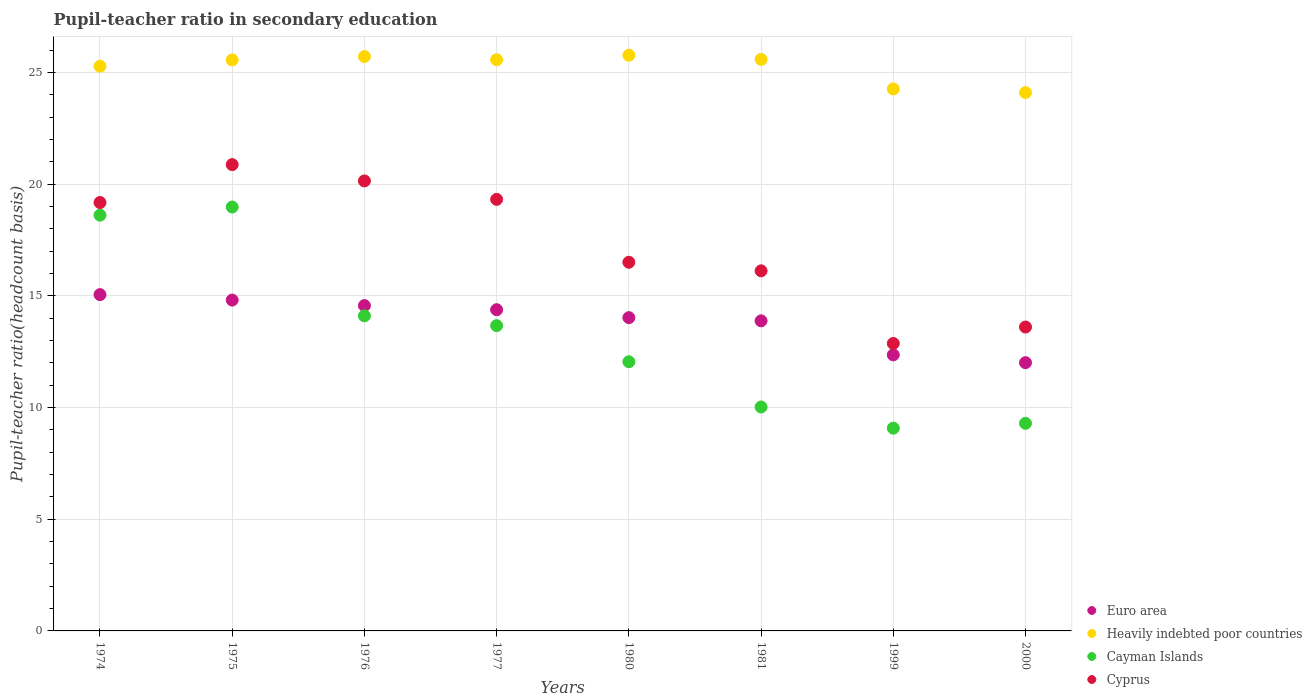Is the number of dotlines equal to the number of legend labels?
Keep it short and to the point. Yes. What is the pupil-teacher ratio in secondary education in Cayman Islands in 2000?
Your answer should be very brief. 9.29. Across all years, what is the maximum pupil-teacher ratio in secondary education in Cayman Islands?
Provide a short and direct response. 18.98. Across all years, what is the minimum pupil-teacher ratio in secondary education in Heavily indebted poor countries?
Keep it short and to the point. 24.1. What is the total pupil-teacher ratio in secondary education in Cayman Islands in the graph?
Make the answer very short. 105.8. What is the difference between the pupil-teacher ratio in secondary education in Heavily indebted poor countries in 1980 and that in 1981?
Keep it short and to the point. 0.19. What is the difference between the pupil-teacher ratio in secondary education in Cyprus in 2000 and the pupil-teacher ratio in secondary education in Heavily indebted poor countries in 1974?
Offer a very short reply. -11.67. What is the average pupil-teacher ratio in secondary education in Euro area per year?
Offer a terse response. 13.88. In the year 1981, what is the difference between the pupil-teacher ratio in secondary education in Heavily indebted poor countries and pupil-teacher ratio in secondary education in Euro area?
Give a very brief answer. 11.7. In how many years, is the pupil-teacher ratio in secondary education in Cayman Islands greater than 22?
Provide a short and direct response. 0. What is the ratio of the pupil-teacher ratio in secondary education in Euro area in 1976 to that in 1977?
Your answer should be very brief. 1.01. Is the difference between the pupil-teacher ratio in secondary education in Heavily indebted poor countries in 1976 and 2000 greater than the difference between the pupil-teacher ratio in secondary education in Euro area in 1976 and 2000?
Ensure brevity in your answer.  No. What is the difference between the highest and the second highest pupil-teacher ratio in secondary education in Cayman Islands?
Your answer should be compact. 0.36. What is the difference between the highest and the lowest pupil-teacher ratio in secondary education in Euro area?
Provide a short and direct response. 3.05. In how many years, is the pupil-teacher ratio in secondary education in Cayman Islands greater than the average pupil-teacher ratio in secondary education in Cayman Islands taken over all years?
Make the answer very short. 4. Is the sum of the pupil-teacher ratio in secondary education in Cyprus in 1977 and 1981 greater than the maximum pupil-teacher ratio in secondary education in Euro area across all years?
Offer a very short reply. Yes. Is it the case that in every year, the sum of the pupil-teacher ratio in secondary education in Heavily indebted poor countries and pupil-teacher ratio in secondary education in Cayman Islands  is greater than the sum of pupil-teacher ratio in secondary education in Cyprus and pupil-teacher ratio in secondary education in Euro area?
Give a very brief answer. Yes. Is the pupil-teacher ratio in secondary education in Cayman Islands strictly less than the pupil-teacher ratio in secondary education in Heavily indebted poor countries over the years?
Ensure brevity in your answer.  Yes. How many years are there in the graph?
Provide a short and direct response. 8. Does the graph contain any zero values?
Offer a terse response. No. How are the legend labels stacked?
Offer a terse response. Vertical. What is the title of the graph?
Ensure brevity in your answer.  Pupil-teacher ratio in secondary education. Does "Chad" appear as one of the legend labels in the graph?
Provide a succinct answer. No. What is the label or title of the Y-axis?
Offer a very short reply. Pupil-teacher ratio(headcount basis). What is the Pupil-teacher ratio(headcount basis) of Euro area in 1974?
Keep it short and to the point. 15.05. What is the Pupil-teacher ratio(headcount basis) in Heavily indebted poor countries in 1974?
Your answer should be very brief. 25.28. What is the Pupil-teacher ratio(headcount basis) of Cayman Islands in 1974?
Provide a short and direct response. 18.61. What is the Pupil-teacher ratio(headcount basis) in Cyprus in 1974?
Ensure brevity in your answer.  19.18. What is the Pupil-teacher ratio(headcount basis) in Euro area in 1975?
Make the answer very short. 14.81. What is the Pupil-teacher ratio(headcount basis) of Heavily indebted poor countries in 1975?
Ensure brevity in your answer.  25.56. What is the Pupil-teacher ratio(headcount basis) of Cayman Islands in 1975?
Your answer should be very brief. 18.98. What is the Pupil-teacher ratio(headcount basis) of Cyprus in 1975?
Provide a short and direct response. 20.87. What is the Pupil-teacher ratio(headcount basis) in Euro area in 1976?
Your response must be concise. 14.56. What is the Pupil-teacher ratio(headcount basis) of Heavily indebted poor countries in 1976?
Ensure brevity in your answer.  25.71. What is the Pupil-teacher ratio(headcount basis) in Cayman Islands in 1976?
Your answer should be compact. 14.1. What is the Pupil-teacher ratio(headcount basis) in Cyprus in 1976?
Your response must be concise. 20.14. What is the Pupil-teacher ratio(headcount basis) of Euro area in 1977?
Keep it short and to the point. 14.38. What is the Pupil-teacher ratio(headcount basis) of Heavily indebted poor countries in 1977?
Offer a very short reply. 25.57. What is the Pupil-teacher ratio(headcount basis) of Cayman Islands in 1977?
Keep it short and to the point. 13.67. What is the Pupil-teacher ratio(headcount basis) of Cyprus in 1977?
Your answer should be very brief. 19.32. What is the Pupil-teacher ratio(headcount basis) in Euro area in 1980?
Keep it short and to the point. 14.02. What is the Pupil-teacher ratio(headcount basis) in Heavily indebted poor countries in 1980?
Ensure brevity in your answer.  25.77. What is the Pupil-teacher ratio(headcount basis) in Cayman Islands in 1980?
Provide a short and direct response. 12.05. What is the Pupil-teacher ratio(headcount basis) of Cyprus in 1980?
Keep it short and to the point. 16.5. What is the Pupil-teacher ratio(headcount basis) in Euro area in 1981?
Offer a terse response. 13.88. What is the Pupil-teacher ratio(headcount basis) in Heavily indebted poor countries in 1981?
Ensure brevity in your answer.  25.58. What is the Pupil-teacher ratio(headcount basis) in Cayman Islands in 1981?
Offer a very short reply. 10.02. What is the Pupil-teacher ratio(headcount basis) in Cyprus in 1981?
Offer a terse response. 16.12. What is the Pupil-teacher ratio(headcount basis) of Euro area in 1999?
Your response must be concise. 12.36. What is the Pupil-teacher ratio(headcount basis) of Heavily indebted poor countries in 1999?
Offer a terse response. 24.26. What is the Pupil-teacher ratio(headcount basis) of Cayman Islands in 1999?
Your answer should be very brief. 9.08. What is the Pupil-teacher ratio(headcount basis) in Cyprus in 1999?
Give a very brief answer. 12.87. What is the Pupil-teacher ratio(headcount basis) in Euro area in 2000?
Provide a succinct answer. 12.01. What is the Pupil-teacher ratio(headcount basis) of Heavily indebted poor countries in 2000?
Keep it short and to the point. 24.1. What is the Pupil-teacher ratio(headcount basis) of Cayman Islands in 2000?
Provide a short and direct response. 9.29. What is the Pupil-teacher ratio(headcount basis) of Cyprus in 2000?
Ensure brevity in your answer.  13.6. Across all years, what is the maximum Pupil-teacher ratio(headcount basis) of Euro area?
Ensure brevity in your answer.  15.05. Across all years, what is the maximum Pupil-teacher ratio(headcount basis) in Heavily indebted poor countries?
Provide a short and direct response. 25.77. Across all years, what is the maximum Pupil-teacher ratio(headcount basis) of Cayman Islands?
Offer a very short reply. 18.98. Across all years, what is the maximum Pupil-teacher ratio(headcount basis) in Cyprus?
Make the answer very short. 20.87. Across all years, what is the minimum Pupil-teacher ratio(headcount basis) of Euro area?
Offer a terse response. 12.01. Across all years, what is the minimum Pupil-teacher ratio(headcount basis) of Heavily indebted poor countries?
Provide a succinct answer. 24.1. Across all years, what is the minimum Pupil-teacher ratio(headcount basis) in Cayman Islands?
Offer a terse response. 9.08. Across all years, what is the minimum Pupil-teacher ratio(headcount basis) of Cyprus?
Keep it short and to the point. 12.87. What is the total Pupil-teacher ratio(headcount basis) in Euro area in the graph?
Ensure brevity in your answer.  111.08. What is the total Pupil-teacher ratio(headcount basis) in Heavily indebted poor countries in the graph?
Offer a very short reply. 201.83. What is the total Pupil-teacher ratio(headcount basis) in Cayman Islands in the graph?
Provide a succinct answer. 105.8. What is the total Pupil-teacher ratio(headcount basis) in Cyprus in the graph?
Make the answer very short. 138.6. What is the difference between the Pupil-teacher ratio(headcount basis) in Euro area in 1974 and that in 1975?
Keep it short and to the point. 0.24. What is the difference between the Pupil-teacher ratio(headcount basis) in Heavily indebted poor countries in 1974 and that in 1975?
Your answer should be compact. -0.28. What is the difference between the Pupil-teacher ratio(headcount basis) in Cayman Islands in 1974 and that in 1975?
Provide a short and direct response. -0.36. What is the difference between the Pupil-teacher ratio(headcount basis) in Cyprus in 1974 and that in 1975?
Offer a terse response. -1.7. What is the difference between the Pupil-teacher ratio(headcount basis) of Euro area in 1974 and that in 1976?
Your answer should be very brief. 0.49. What is the difference between the Pupil-teacher ratio(headcount basis) in Heavily indebted poor countries in 1974 and that in 1976?
Offer a terse response. -0.43. What is the difference between the Pupil-teacher ratio(headcount basis) of Cayman Islands in 1974 and that in 1976?
Give a very brief answer. 4.51. What is the difference between the Pupil-teacher ratio(headcount basis) in Cyprus in 1974 and that in 1976?
Provide a short and direct response. -0.97. What is the difference between the Pupil-teacher ratio(headcount basis) of Euro area in 1974 and that in 1977?
Make the answer very short. 0.68. What is the difference between the Pupil-teacher ratio(headcount basis) in Heavily indebted poor countries in 1974 and that in 1977?
Your answer should be compact. -0.29. What is the difference between the Pupil-teacher ratio(headcount basis) of Cayman Islands in 1974 and that in 1977?
Offer a terse response. 4.94. What is the difference between the Pupil-teacher ratio(headcount basis) of Cyprus in 1974 and that in 1977?
Your answer should be compact. -0.14. What is the difference between the Pupil-teacher ratio(headcount basis) of Euro area in 1974 and that in 1980?
Your response must be concise. 1.03. What is the difference between the Pupil-teacher ratio(headcount basis) in Heavily indebted poor countries in 1974 and that in 1980?
Offer a very short reply. -0.49. What is the difference between the Pupil-teacher ratio(headcount basis) in Cayman Islands in 1974 and that in 1980?
Provide a short and direct response. 6.56. What is the difference between the Pupil-teacher ratio(headcount basis) of Cyprus in 1974 and that in 1980?
Keep it short and to the point. 2.67. What is the difference between the Pupil-teacher ratio(headcount basis) in Euro area in 1974 and that in 1981?
Provide a succinct answer. 1.17. What is the difference between the Pupil-teacher ratio(headcount basis) in Heavily indebted poor countries in 1974 and that in 1981?
Make the answer very short. -0.31. What is the difference between the Pupil-teacher ratio(headcount basis) of Cayman Islands in 1974 and that in 1981?
Provide a succinct answer. 8.59. What is the difference between the Pupil-teacher ratio(headcount basis) in Cyprus in 1974 and that in 1981?
Provide a succinct answer. 3.06. What is the difference between the Pupil-teacher ratio(headcount basis) in Euro area in 1974 and that in 1999?
Give a very brief answer. 2.7. What is the difference between the Pupil-teacher ratio(headcount basis) in Heavily indebted poor countries in 1974 and that in 1999?
Keep it short and to the point. 1.02. What is the difference between the Pupil-teacher ratio(headcount basis) of Cayman Islands in 1974 and that in 1999?
Your response must be concise. 9.54. What is the difference between the Pupil-teacher ratio(headcount basis) of Cyprus in 1974 and that in 1999?
Offer a very short reply. 6.31. What is the difference between the Pupil-teacher ratio(headcount basis) of Euro area in 1974 and that in 2000?
Provide a succinct answer. 3.05. What is the difference between the Pupil-teacher ratio(headcount basis) of Heavily indebted poor countries in 1974 and that in 2000?
Your response must be concise. 1.18. What is the difference between the Pupil-teacher ratio(headcount basis) of Cayman Islands in 1974 and that in 2000?
Offer a terse response. 9.32. What is the difference between the Pupil-teacher ratio(headcount basis) in Cyprus in 1974 and that in 2000?
Provide a short and direct response. 5.57. What is the difference between the Pupil-teacher ratio(headcount basis) of Euro area in 1975 and that in 1976?
Give a very brief answer. 0.25. What is the difference between the Pupil-teacher ratio(headcount basis) in Heavily indebted poor countries in 1975 and that in 1976?
Provide a succinct answer. -0.15. What is the difference between the Pupil-teacher ratio(headcount basis) in Cayman Islands in 1975 and that in 1976?
Offer a terse response. 4.87. What is the difference between the Pupil-teacher ratio(headcount basis) in Cyprus in 1975 and that in 1976?
Keep it short and to the point. 0.73. What is the difference between the Pupil-teacher ratio(headcount basis) of Euro area in 1975 and that in 1977?
Provide a succinct answer. 0.43. What is the difference between the Pupil-teacher ratio(headcount basis) in Heavily indebted poor countries in 1975 and that in 1977?
Offer a very short reply. -0.01. What is the difference between the Pupil-teacher ratio(headcount basis) of Cayman Islands in 1975 and that in 1977?
Give a very brief answer. 5.31. What is the difference between the Pupil-teacher ratio(headcount basis) in Cyprus in 1975 and that in 1977?
Provide a succinct answer. 1.56. What is the difference between the Pupil-teacher ratio(headcount basis) in Euro area in 1975 and that in 1980?
Offer a very short reply. 0.79. What is the difference between the Pupil-teacher ratio(headcount basis) of Heavily indebted poor countries in 1975 and that in 1980?
Your response must be concise. -0.21. What is the difference between the Pupil-teacher ratio(headcount basis) of Cayman Islands in 1975 and that in 1980?
Keep it short and to the point. 6.93. What is the difference between the Pupil-teacher ratio(headcount basis) of Cyprus in 1975 and that in 1980?
Provide a short and direct response. 4.37. What is the difference between the Pupil-teacher ratio(headcount basis) of Euro area in 1975 and that in 1981?
Offer a terse response. 0.93. What is the difference between the Pupil-teacher ratio(headcount basis) in Heavily indebted poor countries in 1975 and that in 1981?
Keep it short and to the point. -0.02. What is the difference between the Pupil-teacher ratio(headcount basis) in Cayman Islands in 1975 and that in 1981?
Keep it short and to the point. 8.95. What is the difference between the Pupil-teacher ratio(headcount basis) in Cyprus in 1975 and that in 1981?
Offer a very short reply. 4.76. What is the difference between the Pupil-teacher ratio(headcount basis) of Euro area in 1975 and that in 1999?
Keep it short and to the point. 2.45. What is the difference between the Pupil-teacher ratio(headcount basis) of Heavily indebted poor countries in 1975 and that in 1999?
Your answer should be very brief. 1.3. What is the difference between the Pupil-teacher ratio(headcount basis) of Cayman Islands in 1975 and that in 1999?
Your response must be concise. 9.9. What is the difference between the Pupil-teacher ratio(headcount basis) of Cyprus in 1975 and that in 1999?
Your response must be concise. 8.01. What is the difference between the Pupil-teacher ratio(headcount basis) in Euro area in 1975 and that in 2000?
Ensure brevity in your answer.  2.8. What is the difference between the Pupil-teacher ratio(headcount basis) of Heavily indebted poor countries in 1975 and that in 2000?
Make the answer very short. 1.46. What is the difference between the Pupil-teacher ratio(headcount basis) of Cayman Islands in 1975 and that in 2000?
Your response must be concise. 9.68. What is the difference between the Pupil-teacher ratio(headcount basis) in Cyprus in 1975 and that in 2000?
Provide a short and direct response. 7.27. What is the difference between the Pupil-teacher ratio(headcount basis) of Euro area in 1976 and that in 1977?
Provide a succinct answer. 0.19. What is the difference between the Pupil-teacher ratio(headcount basis) in Heavily indebted poor countries in 1976 and that in 1977?
Your answer should be compact. 0.14. What is the difference between the Pupil-teacher ratio(headcount basis) in Cayman Islands in 1976 and that in 1977?
Ensure brevity in your answer.  0.44. What is the difference between the Pupil-teacher ratio(headcount basis) in Cyprus in 1976 and that in 1977?
Offer a terse response. 0.83. What is the difference between the Pupil-teacher ratio(headcount basis) in Euro area in 1976 and that in 1980?
Your answer should be compact. 0.54. What is the difference between the Pupil-teacher ratio(headcount basis) of Heavily indebted poor countries in 1976 and that in 1980?
Provide a succinct answer. -0.06. What is the difference between the Pupil-teacher ratio(headcount basis) of Cayman Islands in 1976 and that in 1980?
Provide a short and direct response. 2.05. What is the difference between the Pupil-teacher ratio(headcount basis) in Cyprus in 1976 and that in 1980?
Your answer should be very brief. 3.64. What is the difference between the Pupil-teacher ratio(headcount basis) of Euro area in 1976 and that in 1981?
Keep it short and to the point. 0.68. What is the difference between the Pupil-teacher ratio(headcount basis) of Heavily indebted poor countries in 1976 and that in 1981?
Provide a short and direct response. 0.13. What is the difference between the Pupil-teacher ratio(headcount basis) of Cayman Islands in 1976 and that in 1981?
Offer a terse response. 4.08. What is the difference between the Pupil-teacher ratio(headcount basis) of Cyprus in 1976 and that in 1981?
Provide a short and direct response. 4.03. What is the difference between the Pupil-teacher ratio(headcount basis) of Euro area in 1976 and that in 1999?
Your answer should be very brief. 2.21. What is the difference between the Pupil-teacher ratio(headcount basis) in Heavily indebted poor countries in 1976 and that in 1999?
Offer a very short reply. 1.45. What is the difference between the Pupil-teacher ratio(headcount basis) in Cayman Islands in 1976 and that in 1999?
Keep it short and to the point. 5.03. What is the difference between the Pupil-teacher ratio(headcount basis) of Cyprus in 1976 and that in 1999?
Provide a succinct answer. 7.28. What is the difference between the Pupil-teacher ratio(headcount basis) of Euro area in 1976 and that in 2000?
Your answer should be very brief. 2.56. What is the difference between the Pupil-teacher ratio(headcount basis) in Heavily indebted poor countries in 1976 and that in 2000?
Provide a short and direct response. 1.61. What is the difference between the Pupil-teacher ratio(headcount basis) of Cayman Islands in 1976 and that in 2000?
Keep it short and to the point. 4.81. What is the difference between the Pupil-teacher ratio(headcount basis) of Cyprus in 1976 and that in 2000?
Your response must be concise. 6.54. What is the difference between the Pupil-teacher ratio(headcount basis) of Euro area in 1977 and that in 1980?
Provide a succinct answer. 0.36. What is the difference between the Pupil-teacher ratio(headcount basis) in Heavily indebted poor countries in 1977 and that in 1980?
Give a very brief answer. -0.2. What is the difference between the Pupil-teacher ratio(headcount basis) in Cayman Islands in 1977 and that in 1980?
Keep it short and to the point. 1.62. What is the difference between the Pupil-teacher ratio(headcount basis) in Cyprus in 1977 and that in 1980?
Your answer should be very brief. 2.82. What is the difference between the Pupil-teacher ratio(headcount basis) of Euro area in 1977 and that in 1981?
Provide a short and direct response. 0.5. What is the difference between the Pupil-teacher ratio(headcount basis) of Heavily indebted poor countries in 1977 and that in 1981?
Provide a short and direct response. -0.02. What is the difference between the Pupil-teacher ratio(headcount basis) in Cayman Islands in 1977 and that in 1981?
Your answer should be compact. 3.64. What is the difference between the Pupil-teacher ratio(headcount basis) in Cyprus in 1977 and that in 1981?
Provide a succinct answer. 3.2. What is the difference between the Pupil-teacher ratio(headcount basis) in Euro area in 1977 and that in 1999?
Your response must be concise. 2.02. What is the difference between the Pupil-teacher ratio(headcount basis) of Heavily indebted poor countries in 1977 and that in 1999?
Provide a short and direct response. 1.31. What is the difference between the Pupil-teacher ratio(headcount basis) of Cayman Islands in 1977 and that in 1999?
Ensure brevity in your answer.  4.59. What is the difference between the Pupil-teacher ratio(headcount basis) of Cyprus in 1977 and that in 1999?
Offer a terse response. 6.45. What is the difference between the Pupil-teacher ratio(headcount basis) in Euro area in 1977 and that in 2000?
Your response must be concise. 2.37. What is the difference between the Pupil-teacher ratio(headcount basis) of Heavily indebted poor countries in 1977 and that in 2000?
Give a very brief answer. 1.47. What is the difference between the Pupil-teacher ratio(headcount basis) of Cayman Islands in 1977 and that in 2000?
Your response must be concise. 4.37. What is the difference between the Pupil-teacher ratio(headcount basis) in Cyprus in 1977 and that in 2000?
Provide a short and direct response. 5.71. What is the difference between the Pupil-teacher ratio(headcount basis) in Euro area in 1980 and that in 1981?
Offer a very short reply. 0.14. What is the difference between the Pupil-teacher ratio(headcount basis) of Heavily indebted poor countries in 1980 and that in 1981?
Provide a short and direct response. 0.19. What is the difference between the Pupil-teacher ratio(headcount basis) of Cayman Islands in 1980 and that in 1981?
Give a very brief answer. 2.03. What is the difference between the Pupil-teacher ratio(headcount basis) of Cyprus in 1980 and that in 1981?
Provide a short and direct response. 0.38. What is the difference between the Pupil-teacher ratio(headcount basis) in Euro area in 1980 and that in 1999?
Make the answer very short. 1.67. What is the difference between the Pupil-teacher ratio(headcount basis) in Heavily indebted poor countries in 1980 and that in 1999?
Keep it short and to the point. 1.51. What is the difference between the Pupil-teacher ratio(headcount basis) of Cayman Islands in 1980 and that in 1999?
Ensure brevity in your answer.  2.97. What is the difference between the Pupil-teacher ratio(headcount basis) in Cyprus in 1980 and that in 1999?
Provide a succinct answer. 3.63. What is the difference between the Pupil-teacher ratio(headcount basis) of Euro area in 1980 and that in 2000?
Offer a very short reply. 2.02. What is the difference between the Pupil-teacher ratio(headcount basis) in Heavily indebted poor countries in 1980 and that in 2000?
Give a very brief answer. 1.67. What is the difference between the Pupil-teacher ratio(headcount basis) in Cayman Islands in 1980 and that in 2000?
Offer a very short reply. 2.76. What is the difference between the Pupil-teacher ratio(headcount basis) in Cyprus in 1980 and that in 2000?
Keep it short and to the point. 2.9. What is the difference between the Pupil-teacher ratio(headcount basis) in Euro area in 1981 and that in 1999?
Offer a terse response. 1.52. What is the difference between the Pupil-teacher ratio(headcount basis) in Heavily indebted poor countries in 1981 and that in 1999?
Provide a short and direct response. 1.32. What is the difference between the Pupil-teacher ratio(headcount basis) of Cayman Islands in 1981 and that in 1999?
Keep it short and to the point. 0.95. What is the difference between the Pupil-teacher ratio(headcount basis) in Cyprus in 1981 and that in 1999?
Your answer should be very brief. 3.25. What is the difference between the Pupil-teacher ratio(headcount basis) of Euro area in 1981 and that in 2000?
Give a very brief answer. 1.87. What is the difference between the Pupil-teacher ratio(headcount basis) of Heavily indebted poor countries in 1981 and that in 2000?
Offer a very short reply. 1.49. What is the difference between the Pupil-teacher ratio(headcount basis) in Cayman Islands in 1981 and that in 2000?
Provide a short and direct response. 0.73. What is the difference between the Pupil-teacher ratio(headcount basis) in Cyprus in 1981 and that in 2000?
Make the answer very short. 2.52. What is the difference between the Pupil-teacher ratio(headcount basis) of Euro area in 1999 and that in 2000?
Give a very brief answer. 0.35. What is the difference between the Pupil-teacher ratio(headcount basis) of Heavily indebted poor countries in 1999 and that in 2000?
Give a very brief answer. 0.16. What is the difference between the Pupil-teacher ratio(headcount basis) of Cayman Islands in 1999 and that in 2000?
Make the answer very short. -0.22. What is the difference between the Pupil-teacher ratio(headcount basis) of Cyprus in 1999 and that in 2000?
Offer a terse response. -0.74. What is the difference between the Pupil-teacher ratio(headcount basis) in Euro area in 1974 and the Pupil-teacher ratio(headcount basis) in Heavily indebted poor countries in 1975?
Offer a terse response. -10.51. What is the difference between the Pupil-teacher ratio(headcount basis) of Euro area in 1974 and the Pupil-teacher ratio(headcount basis) of Cayman Islands in 1975?
Give a very brief answer. -3.92. What is the difference between the Pupil-teacher ratio(headcount basis) in Euro area in 1974 and the Pupil-teacher ratio(headcount basis) in Cyprus in 1975?
Your response must be concise. -5.82. What is the difference between the Pupil-teacher ratio(headcount basis) in Heavily indebted poor countries in 1974 and the Pupil-teacher ratio(headcount basis) in Cayman Islands in 1975?
Provide a succinct answer. 6.3. What is the difference between the Pupil-teacher ratio(headcount basis) of Heavily indebted poor countries in 1974 and the Pupil-teacher ratio(headcount basis) of Cyprus in 1975?
Your response must be concise. 4.4. What is the difference between the Pupil-teacher ratio(headcount basis) in Cayman Islands in 1974 and the Pupil-teacher ratio(headcount basis) in Cyprus in 1975?
Provide a succinct answer. -2.26. What is the difference between the Pupil-teacher ratio(headcount basis) of Euro area in 1974 and the Pupil-teacher ratio(headcount basis) of Heavily indebted poor countries in 1976?
Ensure brevity in your answer.  -10.66. What is the difference between the Pupil-teacher ratio(headcount basis) of Euro area in 1974 and the Pupil-teacher ratio(headcount basis) of Cayman Islands in 1976?
Make the answer very short. 0.95. What is the difference between the Pupil-teacher ratio(headcount basis) of Euro area in 1974 and the Pupil-teacher ratio(headcount basis) of Cyprus in 1976?
Ensure brevity in your answer.  -5.09. What is the difference between the Pupil-teacher ratio(headcount basis) of Heavily indebted poor countries in 1974 and the Pupil-teacher ratio(headcount basis) of Cayman Islands in 1976?
Your answer should be very brief. 11.17. What is the difference between the Pupil-teacher ratio(headcount basis) in Heavily indebted poor countries in 1974 and the Pupil-teacher ratio(headcount basis) in Cyprus in 1976?
Offer a very short reply. 5.13. What is the difference between the Pupil-teacher ratio(headcount basis) of Cayman Islands in 1974 and the Pupil-teacher ratio(headcount basis) of Cyprus in 1976?
Offer a very short reply. -1.53. What is the difference between the Pupil-teacher ratio(headcount basis) in Euro area in 1974 and the Pupil-teacher ratio(headcount basis) in Heavily indebted poor countries in 1977?
Offer a very short reply. -10.51. What is the difference between the Pupil-teacher ratio(headcount basis) in Euro area in 1974 and the Pupil-teacher ratio(headcount basis) in Cayman Islands in 1977?
Provide a short and direct response. 1.39. What is the difference between the Pupil-teacher ratio(headcount basis) of Euro area in 1974 and the Pupil-teacher ratio(headcount basis) of Cyprus in 1977?
Make the answer very short. -4.26. What is the difference between the Pupil-teacher ratio(headcount basis) in Heavily indebted poor countries in 1974 and the Pupil-teacher ratio(headcount basis) in Cayman Islands in 1977?
Your answer should be very brief. 11.61. What is the difference between the Pupil-teacher ratio(headcount basis) of Heavily indebted poor countries in 1974 and the Pupil-teacher ratio(headcount basis) of Cyprus in 1977?
Give a very brief answer. 5.96. What is the difference between the Pupil-teacher ratio(headcount basis) in Cayman Islands in 1974 and the Pupil-teacher ratio(headcount basis) in Cyprus in 1977?
Your answer should be compact. -0.71. What is the difference between the Pupil-teacher ratio(headcount basis) of Euro area in 1974 and the Pupil-teacher ratio(headcount basis) of Heavily indebted poor countries in 1980?
Ensure brevity in your answer.  -10.72. What is the difference between the Pupil-teacher ratio(headcount basis) in Euro area in 1974 and the Pupil-teacher ratio(headcount basis) in Cayman Islands in 1980?
Provide a succinct answer. 3. What is the difference between the Pupil-teacher ratio(headcount basis) in Euro area in 1974 and the Pupil-teacher ratio(headcount basis) in Cyprus in 1980?
Provide a succinct answer. -1.45. What is the difference between the Pupil-teacher ratio(headcount basis) in Heavily indebted poor countries in 1974 and the Pupil-teacher ratio(headcount basis) in Cayman Islands in 1980?
Make the answer very short. 13.23. What is the difference between the Pupil-teacher ratio(headcount basis) in Heavily indebted poor countries in 1974 and the Pupil-teacher ratio(headcount basis) in Cyprus in 1980?
Give a very brief answer. 8.78. What is the difference between the Pupil-teacher ratio(headcount basis) in Cayman Islands in 1974 and the Pupil-teacher ratio(headcount basis) in Cyprus in 1980?
Offer a very short reply. 2.11. What is the difference between the Pupil-teacher ratio(headcount basis) of Euro area in 1974 and the Pupil-teacher ratio(headcount basis) of Heavily indebted poor countries in 1981?
Offer a terse response. -10.53. What is the difference between the Pupil-teacher ratio(headcount basis) in Euro area in 1974 and the Pupil-teacher ratio(headcount basis) in Cayman Islands in 1981?
Ensure brevity in your answer.  5.03. What is the difference between the Pupil-teacher ratio(headcount basis) of Euro area in 1974 and the Pupil-teacher ratio(headcount basis) of Cyprus in 1981?
Provide a succinct answer. -1.06. What is the difference between the Pupil-teacher ratio(headcount basis) of Heavily indebted poor countries in 1974 and the Pupil-teacher ratio(headcount basis) of Cayman Islands in 1981?
Provide a short and direct response. 15.25. What is the difference between the Pupil-teacher ratio(headcount basis) of Heavily indebted poor countries in 1974 and the Pupil-teacher ratio(headcount basis) of Cyprus in 1981?
Your answer should be very brief. 9.16. What is the difference between the Pupil-teacher ratio(headcount basis) in Cayman Islands in 1974 and the Pupil-teacher ratio(headcount basis) in Cyprus in 1981?
Offer a terse response. 2.49. What is the difference between the Pupil-teacher ratio(headcount basis) of Euro area in 1974 and the Pupil-teacher ratio(headcount basis) of Heavily indebted poor countries in 1999?
Ensure brevity in your answer.  -9.21. What is the difference between the Pupil-teacher ratio(headcount basis) in Euro area in 1974 and the Pupil-teacher ratio(headcount basis) in Cayman Islands in 1999?
Ensure brevity in your answer.  5.98. What is the difference between the Pupil-teacher ratio(headcount basis) in Euro area in 1974 and the Pupil-teacher ratio(headcount basis) in Cyprus in 1999?
Your answer should be compact. 2.19. What is the difference between the Pupil-teacher ratio(headcount basis) in Heavily indebted poor countries in 1974 and the Pupil-teacher ratio(headcount basis) in Cayman Islands in 1999?
Offer a very short reply. 16.2. What is the difference between the Pupil-teacher ratio(headcount basis) in Heavily indebted poor countries in 1974 and the Pupil-teacher ratio(headcount basis) in Cyprus in 1999?
Ensure brevity in your answer.  12.41. What is the difference between the Pupil-teacher ratio(headcount basis) in Cayman Islands in 1974 and the Pupil-teacher ratio(headcount basis) in Cyprus in 1999?
Ensure brevity in your answer.  5.74. What is the difference between the Pupil-teacher ratio(headcount basis) of Euro area in 1974 and the Pupil-teacher ratio(headcount basis) of Heavily indebted poor countries in 2000?
Provide a succinct answer. -9.04. What is the difference between the Pupil-teacher ratio(headcount basis) in Euro area in 1974 and the Pupil-teacher ratio(headcount basis) in Cayman Islands in 2000?
Provide a succinct answer. 5.76. What is the difference between the Pupil-teacher ratio(headcount basis) of Euro area in 1974 and the Pupil-teacher ratio(headcount basis) of Cyprus in 2000?
Offer a terse response. 1.45. What is the difference between the Pupil-teacher ratio(headcount basis) in Heavily indebted poor countries in 1974 and the Pupil-teacher ratio(headcount basis) in Cayman Islands in 2000?
Make the answer very short. 15.98. What is the difference between the Pupil-teacher ratio(headcount basis) of Heavily indebted poor countries in 1974 and the Pupil-teacher ratio(headcount basis) of Cyprus in 2000?
Your answer should be very brief. 11.67. What is the difference between the Pupil-teacher ratio(headcount basis) of Cayman Islands in 1974 and the Pupil-teacher ratio(headcount basis) of Cyprus in 2000?
Offer a very short reply. 5.01. What is the difference between the Pupil-teacher ratio(headcount basis) of Euro area in 1975 and the Pupil-teacher ratio(headcount basis) of Heavily indebted poor countries in 1976?
Provide a short and direct response. -10.9. What is the difference between the Pupil-teacher ratio(headcount basis) in Euro area in 1975 and the Pupil-teacher ratio(headcount basis) in Cayman Islands in 1976?
Your response must be concise. 0.71. What is the difference between the Pupil-teacher ratio(headcount basis) of Euro area in 1975 and the Pupil-teacher ratio(headcount basis) of Cyprus in 1976?
Your answer should be compact. -5.33. What is the difference between the Pupil-teacher ratio(headcount basis) in Heavily indebted poor countries in 1975 and the Pupil-teacher ratio(headcount basis) in Cayman Islands in 1976?
Your answer should be very brief. 11.46. What is the difference between the Pupil-teacher ratio(headcount basis) in Heavily indebted poor countries in 1975 and the Pupil-teacher ratio(headcount basis) in Cyprus in 1976?
Keep it short and to the point. 5.42. What is the difference between the Pupil-teacher ratio(headcount basis) in Cayman Islands in 1975 and the Pupil-teacher ratio(headcount basis) in Cyprus in 1976?
Ensure brevity in your answer.  -1.17. What is the difference between the Pupil-teacher ratio(headcount basis) of Euro area in 1975 and the Pupil-teacher ratio(headcount basis) of Heavily indebted poor countries in 1977?
Provide a short and direct response. -10.76. What is the difference between the Pupil-teacher ratio(headcount basis) of Euro area in 1975 and the Pupil-teacher ratio(headcount basis) of Cayman Islands in 1977?
Provide a succinct answer. 1.14. What is the difference between the Pupil-teacher ratio(headcount basis) in Euro area in 1975 and the Pupil-teacher ratio(headcount basis) in Cyprus in 1977?
Your answer should be very brief. -4.51. What is the difference between the Pupil-teacher ratio(headcount basis) of Heavily indebted poor countries in 1975 and the Pupil-teacher ratio(headcount basis) of Cayman Islands in 1977?
Your response must be concise. 11.89. What is the difference between the Pupil-teacher ratio(headcount basis) in Heavily indebted poor countries in 1975 and the Pupil-teacher ratio(headcount basis) in Cyprus in 1977?
Your answer should be compact. 6.24. What is the difference between the Pupil-teacher ratio(headcount basis) in Cayman Islands in 1975 and the Pupil-teacher ratio(headcount basis) in Cyprus in 1977?
Your answer should be compact. -0.34. What is the difference between the Pupil-teacher ratio(headcount basis) of Euro area in 1975 and the Pupil-teacher ratio(headcount basis) of Heavily indebted poor countries in 1980?
Offer a very short reply. -10.96. What is the difference between the Pupil-teacher ratio(headcount basis) of Euro area in 1975 and the Pupil-teacher ratio(headcount basis) of Cayman Islands in 1980?
Provide a succinct answer. 2.76. What is the difference between the Pupil-teacher ratio(headcount basis) in Euro area in 1975 and the Pupil-teacher ratio(headcount basis) in Cyprus in 1980?
Offer a terse response. -1.69. What is the difference between the Pupil-teacher ratio(headcount basis) in Heavily indebted poor countries in 1975 and the Pupil-teacher ratio(headcount basis) in Cayman Islands in 1980?
Ensure brevity in your answer.  13.51. What is the difference between the Pupil-teacher ratio(headcount basis) of Heavily indebted poor countries in 1975 and the Pupil-teacher ratio(headcount basis) of Cyprus in 1980?
Ensure brevity in your answer.  9.06. What is the difference between the Pupil-teacher ratio(headcount basis) in Cayman Islands in 1975 and the Pupil-teacher ratio(headcount basis) in Cyprus in 1980?
Your response must be concise. 2.47. What is the difference between the Pupil-teacher ratio(headcount basis) of Euro area in 1975 and the Pupil-teacher ratio(headcount basis) of Heavily indebted poor countries in 1981?
Ensure brevity in your answer.  -10.77. What is the difference between the Pupil-teacher ratio(headcount basis) in Euro area in 1975 and the Pupil-teacher ratio(headcount basis) in Cayman Islands in 1981?
Provide a short and direct response. 4.79. What is the difference between the Pupil-teacher ratio(headcount basis) in Euro area in 1975 and the Pupil-teacher ratio(headcount basis) in Cyprus in 1981?
Your answer should be very brief. -1.31. What is the difference between the Pupil-teacher ratio(headcount basis) of Heavily indebted poor countries in 1975 and the Pupil-teacher ratio(headcount basis) of Cayman Islands in 1981?
Ensure brevity in your answer.  15.54. What is the difference between the Pupil-teacher ratio(headcount basis) in Heavily indebted poor countries in 1975 and the Pupil-teacher ratio(headcount basis) in Cyprus in 1981?
Ensure brevity in your answer.  9.44. What is the difference between the Pupil-teacher ratio(headcount basis) of Cayman Islands in 1975 and the Pupil-teacher ratio(headcount basis) of Cyprus in 1981?
Your answer should be compact. 2.86. What is the difference between the Pupil-teacher ratio(headcount basis) in Euro area in 1975 and the Pupil-teacher ratio(headcount basis) in Heavily indebted poor countries in 1999?
Your answer should be compact. -9.45. What is the difference between the Pupil-teacher ratio(headcount basis) of Euro area in 1975 and the Pupil-teacher ratio(headcount basis) of Cayman Islands in 1999?
Offer a terse response. 5.73. What is the difference between the Pupil-teacher ratio(headcount basis) in Euro area in 1975 and the Pupil-teacher ratio(headcount basis) in Cyprus in 1999?
Offer a terse response. 1.94. What is the difference between the Pupil-teacher ratio(headcount basis) in Heavily indebted poor countries in 1975 and the Pupil-teacher ratio(headcount basis) in Cayman Islands in 1999?
Offer a terse response. 16.48. What is the difference between the Pupil-teacher ratio(headcount basis) of Heavily indebted poor countries in 1975 and the Pupil-teacher ratio(headcount basis) of Cyprus in 1999?
Your answer should be compact. 12.69. What is the difference between the Pupil-teacher ratio(headcount basis) in Cayman Islands in 1975 and the Pupil-teacher ratio(headcount basis) in Cyprus in 1999?
Your response must be concise. 6.11. What is the difference between the Pupil-teacher ratio(headcount basis) in Euro area in 1975 and the Pupil-teacher ratio(headcount basis) in Heavily indebted poor countries in 2000?
Your answer should be compact. -9.29. What is the difference between the Pupil-teacher ratio(headcount basis) of Euro area in 1975 and the Pupil-teacher ratio(headcount basis) of Cayman Islands in 2000?
Keep it short and to the point. 5.52. What is the difference between the Pupil-teacher ratio(headcount basis) in Euro area in 1975 and the Pupil-teacher ratio(headcount basis) in Cyprus in 2000?
Make the answer very short. 1.21. What is the difference between the Pupil-teacher ratio(headcount basis) of Heavily indebted poor countries in 1975 and the Pupil-teacher ratio(headcount basis) of Cayman Islands in 2000?
Your answer should be compact. 16.27. What is the difference between the Pupil-teacher ratio(headcount basis) of Heavily indebted poor countries in 1975 and the Pupil-teacher ratio(headcount basis) of Cyprus in 2000?
Make the answer very short. 11.96. What is the difference between the Pupil-teacher ratio(headcount basis) of Cayman Islands in 1975 and the Pupil-teacher ratio(headcount basis) of Cyprus in 2000?
Provide a short and direct response. 5.37. What is the difference between the Pupil-teacher ratio(headcount basis) of Euro area in 1976 and the Pupil-teacher ratio(headcount basis) of Heavily indebted poor countries in 1977?
Give a very brief answer. -11. What is the difference between the Pupil-teacher ratio(headcount basis) in Euro area in 1976 and the Pupil-teacher ratio(headcount basis) in Cayman Islands in 1977?
Your answer should be very brief. 0.9. What is the difference between the Pupil-teacher ratio(headcount basis) in Euro area in 1976 and the Pupil-teacher ratio(headcount basis) in Cyprus in 1977?
Keep it short and to the point. -4.75. What is the difference between the Pupil-teacher ratio(headcount basis) of Heavily indebted poor countries in 1976 and the Pupil-teacher ratio(headcount basis) of Cayman Islands in 1977?
Ensure brevity in your answer.  12.04. What is the difference between the Pupil-teacher ratio(headcount basis) of Heavily indebted poor countries in 1976 and the Pupil-teacher ratio(headcount basis) of Cyprus in 1977?
Ensure brevity in your answer.  6.39. What is the difference between the Pupil-teacher ratio(headcount basis) of Cayman Islands in 1976 and the Pupil-teacher ratio(headcount basis) of Cyprus in 1977?
Your answer should be very brief. -5.21. What is the difference between the Pupil-teacher ratio(headcount basis) in Euro area in 1976 and the Pupil-teacher ratio(headcount basis) in Heavily indebted poor countries in 1980?
Your response must be concise. -11.21. What is the difference between the Pupil-teacher ratio(headcount basis) in Euro area in 1976 and the Pupil-teacher ratio(headcount basis) in Cayman Islands in 1980?
Ensure brevity in your answer.  2.51. What is the difference between the Pupil-teacher ratio(headcount basis) of Euro area in 1976 and the Pupil-teacher ratio(headcount basis) of Cyprus in 1980?
Your answer should be very brief. -1.94. What is the difference between the Pupil-teacher ratio(headcount basis) in Heavily indebted poor countries in 1976 and the Pupil-teacher ratio(headcount basis) in Cayman Islands in 1980?
Make the answer very short. 13.66. What is the difference between the Pupil-teacher ratio(headcount basis) of Heavily indebted poor countries in 1976 and the Pupil-teacher ratio(headcount basis) of Cyprus in 1980?
Give a very brief answer. 9.21. What is the difference between the Pupil-teacher ratio(headcount basis) of Cayman Islands in 1976 and the Pupil-teacher ratio(headcount basis) of Cyprus in 1980?
Keep it short and to the point. -2.4. What is the difference between the Pupil-teacher ratio(headcount basis) of Euro area in 1976 and the Pupil-teacher ratio(headcount basis) of Heavily indebted poor countries in 1981?
Ensure brevity in your answer.  -11.02. What is the difference between the Pupil-teacher ratio(headcount basis) of Euro area in 1976 and the Pupil-teacher ratio(headcount basis) of Cayman Islands in 1981?
Give a very brief answer. 4.54. What is the difference between the Pupil-teacher ratio(headcount basis) of Euro area in 1976 and the Pupil-teacher ratio(headcount basis) of Cyprus in 1981?
Provide a short and direct response. -1.55. What is the difference between the Pupil-teacher ratio(headcount basis) in Heavily indebted poor countries in 1976 and the Pupil-teacher ratio(headcount basis) in Cayman Islands in 1981?
Provide a succinct answer. 15.69. What is the difference between the Pupil-teacher ratio(headcount basis) of Heavily indebted poor countries in 1976 and the Pupil-teacher ratio(headcount basis) of Cyprus in 1981?
Offer a terse response. 9.59. What is the difference between the Pupil-teacher ratio(headcount basis) in Cayman Islands in 1976 and the Pupil-teacher ratio(headcount basis) in Cyprus in 1981?
Provide a short and direct response. -2.02. What is the difference between the Pupil-teacher ratio(headcount basis) of Euro area in 1976 and the Pupil-teacher ratio(headcount basis) of Heavily indebted poor countries in 1999?
Provide a short and direct response. -9.7. What is the difference between the Pupil-teacher ratio(headcount basis) in Euro area in 1976 and the Pupil-teacher ratio(headcount basis) in Cayman Islands in 1999?
Your response must be concise. 5.49. What is the difference between the Pupil-teacher ratio(headcount basis) in Euro area in 1976 and the Pupil-teacher ratio(headcount basis) in Cyprus in 1999?
Provide a short and direct response. 1.7. What is the difference between the Pupil-teacher ratio(headcount basis) in Heavily indebted poor countries in 1976 and the Pupil-teacher ratio(headcount basis) in Cayman Islands in 1999?
Ensure brevity in your answer.  16.64. What is the difference between the Pupil-teacher ratio(headcount basis) in Heavily indebted poor countries in 1976 and the Pupil-teacher ratio(headcount basis) in Cyprus in 1999?
Offer a very short reply. 12.84. What is the difference between the Pupil-teacher ratio(headcount basis) of Cayman Islands in 1976 and the Pupil-teacher ratio(headcount basis) of Cyprus in 1999?
Provide a short and direct response. 1.24. What is the difference between the Pupil-teacher ratio(headcount basis) in Euro area in 1976 and the Pupil-teacher ratio(headcount basis) in Heavily indebted poor countries in 2000?
Provide a short and direct response. -9.53. What is the difference between the Pupil-teacher ratio(headcount basis) in Euro area in 1976 and the Pupil-teacher ratio(headcount basis) in Cayman Islands in 2000?
Your answer should be very brief. 5.27. What is the difference between the Pupil-teacher ratio(headcount basis) in Euro area in 1976 and the Pupil-teacher ratio(headcount basis) in Cyprus in 2000?
Offer a terse response. 0.96. What is the difference between the Pupil-teacher ratio(headcount basis) of Heavily indebted poor countries in 1976 and the Pupil-teacher ratio(headcount basis) of Cayman Islands in 2000?
Your answer should be compact. 16.42. What is the difference between the Pupil-teacher ratio(headcount basis) in Heavily indebted poor countries in 1976 and the Pupil-teacher ratio(headcount basis) in Cyprus in 2000?
Your response must be concise. 12.11. What is the difference between the Pupil-teacher ratio(headcount basis) in Cayman Islands in 1976 and the Pupil-teacher ratio(headcount basis) in Cyprus in 2000?
Your answer should be very brief. 0.5. What is the difference between the Pupil-teacher ratio(headcount basis) of Euro area in 1977 and the Pupil-teacher ratio(headcount basis) of Heavily indebted poor countries in 1980?
Keep it short and to the point. -11.39. What is the difference between the Pupil-teacher ratio(headcount basis) in Euro area in 1977 and the Pupil-teacher ratio(headcount basis) in Cayman Islands in 1980?
Ensure brevity in your answer.  2.33. What is the difference between the Pupil-teacher ratio(headcount basis) of Euro area in 1977 and the Pupil-teacher ratio(headcount basis) of Cyprus in 1980?
Your answer should be compact. -2.12. What is the difference between the Pupil-teacher ratio(headcount basis) of Heavily indebted poor countries in 1977 and the Pupil-teacher ratio(headcount basis) of Cayman Islands in 1980?
Your response must be concise. 13.52. What is the difference between the Pupil-teacher ratio(headcount basis) in Heavily indebted poor countries in 1977 and the Pupil-teacher ratio(headcount basis) in Cyprus in 1980?
Provide a short and direct response. 9.07. What is the difference between the Pupil-teacher ratio(headcount basis) of Cayman Islands in 1977 and the Pupil-teacher ratio(headcount basis) of Cyprus in 1980?
Provide a short and direct response. -2.84. What is the difference between the Pupil-teacher ratio(headcount basis) of Euro area in 1977 and the Pupil-teacher ratio(headcount basis) of Heavily indebted poor countries in 1981?
Your answer should be very brief. -11.21. What is the difference between the Pupil-teacher ratio(headcount basis) in Euro area in 1977 and the Pupil-teacher ratio(headcount basis) in Cayman Islands in 1981?
Your answer should be very brief. 4.35. What is the difference between the Pupil-teacher ratio(headcount basis) in Euro area in 1977 and the Pupil-teacher ratio(headcount basis) in Cyprus in 1981?
Make the answer very short. -1.74. What is the difference between the Pupil-teacher ratio(headcount basis) in Heavily indebted poor countries in 1977 and the Pupil-teacher ratio(headcount basis) in Cayman Islands in 1981?
Make the answer very short. 15.54. What is the difference between the Pupil-teacher ratio(headcount basis) in Heavily indebted poor countries in 1977 and the Pupil-teacher ratio(headcount basis) in Cyprus in 1981?
Make the answer very short. 9.45. What is the difference between the Pupil-teacher ratio(headcount basis) in Cayman Islands in 1977 and the Pupil-teacher ratio(headcount basis) in Cyprus in 1981?
Your answer should be compact. -2.45. What is the difference between the Pupil-teacher ratio(headcount basis) in Euro area in 1977 and the Pupil-teacher ratio(headcount basis) in Heavily indebted poor countries in 1999?
Your answer should be compact. -9.88. What is the difference between the Pupil-teacher ratio(headcount basis) in Euro area in 1977 and the Pupil-teacher ratio(headcount basis) in Cayman Islands in 1999?
Ensure brevity in your answer.  5.3. What is the difference between the Pupil-teacher ratio(headcount basis) of Euro area in 1977 and the Pupil-teacher ratio(headcount basis) of Cyprus in 1999?
Provide a short and direct response. 1.51. What is the difference between the Pupil-teacher ratio(headcount basis) of Heavily indebted poor countries in 1977 and the Pupil-teacher ratio(headcount basis) of Cayman Islands in 1999?
Keep it short and to the point. 16.49. What is the difference between the Pupil-teacher ratio(headcount basis) of Heavily indebted poor countries in 1977 and the Pupil-teacher ratio(headcount basis) of Cyprus in 1999?
Keep it short and to the point. 12.7. What is the difference between the Pupil-teacher ratio(headcount basis) of Cayman Islands in 1977 and the Pupil-teacher ratio(headcount basis) of Cyprus in 1999?
Offer a very short reply. 0.8. What is the difference between the Pupil-teacher ratio(headcount basis) of Euro area in 1977 and the Pupil-teacher ratio(headcount basis) of Heavily indebted poor countries in 2000?
Provide a succinct answer. -9.72. What is the difference between the Pupil-teacher ratio(headcount basis) of Euro area in 1977 and the Pupil-teacher ratio(headcount basis) of Cayman Islands in 2000?
Make the answer very short. 5.09. What is the difference between the Pupil-teacher ratio(headcount basis) in Euro area in 1977 and the Pupil-teacher ratio(headcount basis) in Cyprus in 2000?
Keep it short and to the point. 0.78. What is the difference between the Pupil-teacher ratio(headcount basis) of Heavily indebted poor countries in 1977 and the Pupil-teacher ratio(headcount basis) of Cayman Islands in 2000?
Give a very brief answer. 16.27. What is the difference between the Pupil-teacher ratio(headcount basis) of Heavily indebted poor countries in 1977 and the Pupil-teacher ratio(headcount basis) of Cyprus in 2000?
Make the answer very short. 11.97. What is the difference between the Pupil-teacher ratio(headcount basis) of Cayman Islands in 1977 and the Pupil-teacher ratio(headcount basis) of Cyprus in 2000?
Provide a short and direct response. 0.06. What is the difference between the Pupil-teacher ratio(headcount basis) of Euro area in 1980 and the Pupil-teacher ratio(headcount basis) of Heavily indebted poor countries in 1981?
Your response must be concise. -11.56. What is the difference between the Pupil-teacher ratio(headcount basis) of Euro area in 1980 and the Pupil-teacher ratio(headcount basis) of Cayman Islands in 1981?
Ensure brevity in your answer.  4. What is the difference between the Pupil-teacher ratio(headcount basis) of Euro area in 1980 and the Pupil-teacher ratio(headcount basis) of Cyprus in 1981?
Your answer should be very brief. -2.1. What is the difference between the Pupil-teacher ratio(headcount basis) of Heavily indebted poor countries in 1980 and the Pupil-teacher ratio(headcount basis) of Cayman Islands in 1981?
Provide a succinct answer. 15.75. What is the difference between the Pupil-teacher ratio(headcount basis) of Heavily indebted poor countries in 1980 and the Pupil-teacher ratio(headcount basis) of Cyprus in 1981?
Your answer should be compact. 9.65. What is the difference between the Pupil-teacher ratio(headcount basis) in Cayman Islands in 1980 and the Pupil-teacher ratio(headcount basis) in Cyprus in 1981?
Provide a succinct answer. -4.07. What is the difference between the Pupil-teacher ratio(headcount basis) of Euro area in 1980 and the Pupil-teacher ratio(headcount basis) of Heavily indebted poor countries in 1999?
Provide a succinct answer. -10.24. What is the difference between the Pupil-teacher ratio(headcount basis) of Euro area in 1980 and the Pupil-teacher ratio(headcount basis) of Cayman Islands in 1999?
Ensure brevity in your answer.  4.95. What is the difference between the Pupil-teacher ratio(headcount basis) in Euro area in 1980 and the Pupil-teacher ratio(headcount basis) in Cyprus in 1999?
Your response must be concise. 1.16. What is the difference between the Pupil-teacher ratio(headcount basis) of Heavily indebted poor countries in 1980 and the Pupil-teacher ratio(headcount basis) of Cayman Islands in 1999?
Make the answer very short. 16.69. What is the difference between the Pupil-teacher ratio(headcount basis) in Heavily indebted poor countries in 1980 and the Pupil-teacher ratio(headcount basis) in Cyprus in 1999?
Offer a terse response. 12.9. What is the difference between the Pupil-teacher ratio(headcount basis) in Cayman Islands in 1980 and the Pupil-teacher ratio(headcount basis) in Cyprus in 1999?
Give a very brief answer. -0.82. What is the difference between the Pupil-teacher ratio(headcount basis) of Euro area in 1980 and the Pupil-teacher ratio(headcount basis) of Heavily indebted poor countries in 2000?
Ensure brevity in your answer.  -10.07. What is the difference between the Pupil-teacher ratio(headcount basis) of Euro area in 1980 and the Pupil-teacher ratio(headcount basis) of Cayman Islands in 2000?
Provide a short and direct response. 4.73. What is the difference between the Pupil-teacher ratio(headcount basis) of Euro area in 1980 and the Pupil-teacher ratio(headcount basis) of Cyprus in 2000?
Your response must be concise. 0.42. What is the difference between the Pupil-teacher ratio(headcount basis) in Heavily indebted poor countries in 1980 and the Pupil-teacher ratio(headcount basis) in Cayman Islands in 2000?
Offer a very short reply. 16.48. What is the difference between the Pupil-teacher ratio(headcount basis) of Heavily indebted poor countries in 1980 and the Pupil-teacher ratio(headcount basis) of Cyprus in 2000?
Provide a short and direct response. 12.17. What is the difference between the Pupil-teacher ratio(headcount basis) of Cayman Islands in 1980 and the Pupil-teacher ratio(headcount basis) of Cyprus in 2000?
Your answer should be very brief. -1.55. What is the difference between the Pupil-teacher ratio(headcount basis) of Euro area in 1981 and the Pupil-teacher ratio(headcount basis) of Heavily indebted poor countries in 1999?
Keep it short and to the point. -10.38. What is the difference between the Pupil-teacher ratio(headcount basis) in Euro area in 1981 and the Pupil-teacher ratio(headcount basis) in Cayman Islands in 1999?
Provide a short and direct response. 4.8. What is the difference between the Pupil-teacher ratio(headcount basis) of Euro area in 1981 and the Pupil-teacher ratio(headcount basis) of Cyprus in 1999?
Your response must be concise. 1.01. What is the difference between the Pupil-teacher ratio(headcount basis) in Heavily indebted poor countries in 1981 and the Pupil-teacher ratio(headcount basis) in Cayman Islands in 1999?
Ensure brevity in your answer.  16.51. What is the difference between the Pupil-teacher ratio(headcount basis) in Heavily indebted poor countries in 1981 and the Pupil-teacher ratio(headcount basis) in Cyprus in 1999?
Provide a short and direct response. 12.72. What is the difference between the Pupil-teacher ratio(headcount basis) of Cayman Islands in 1981 and the Pupil-teacher ratio(headcount basis) of Cyprus in 1999?
Make the answer very short. -2.84. What is the difference between the Pupil-teacher ratio(headcount basis) in Euro area in 1981 and the Pupil-teacher ratio(headcount basis) in Heavily indebted poor countries in 2000?
Your response must be concise. -10.22. What is the difference between the Pupil-teacher ratio(headcount basis) of Euro area in 1981 and the Pupil-teacher ratio(headcount basis) of Cayman Islands in 2000?
Your answer should be very brief. 4.59. What is the difference between the Pupil-teacher ratio(headcount basis) of Euro area in 1981 and the Pupil-teacher ratio(headcount basis) of Cyprus in 2000?
Offer a terse response. 0.28. What is the difference between the Pupil-teacher ratio(headcount basis) in Heavily indebted poor countries in 1981 and the Pupil-teacher ratio(headcount basis) in Cayman Islands in 2000?
Your response must be concise. 16.29. What is the difference between the Pupil-teacher ratio(headcount basis) of Heavily indebted poor countries in 1981 and the Pupil-teacher ratio(headcount basis) of Cyprus in 2000?
Provide a succinct answer. 11.98. What is the difference between the Pupil-teacher ratio(headcount basis) in Cayman Islands in 1981 and the Pupil-teacher ratio(headcount basis) in Cyprus in 2000?
Make the answer very short. -3.58. What is the difference between the Pupil-teacher ratio(headcount basis) of Euro area in 1999 and the Pupil-teacher ratio(headcount basis) of Heavily indebted poor countries in 2000?
Keep it short and to the point. -11.74. What is the difference between the Pupil-teacher ratio(headcount basis) of Euro area in 1999 and the Pupil-teacher ratio(headcount basis) of Cayman Islands in 2000?
Provide a succinct answer. 3.06. What is the difference between the Pupil-teacher ratio(headcount basis) of Euro area in 1999 and the Pupil-teacher ratio(headcount basis) of Cyprus in 2000?
Provide a succinct answer. -1.25. What is the difference between the Pupil-teacher ratio(headcount basis) of Heavily indebted poor countries in 1999 and the Pupil-teacher ratio(headcount basis) of Cayman Islands in 2000?
Provide a short and direct response. 14.97. What is the difference between the Pupil-teacher ratio(headcount basis) in Heavily indebted poor countries in 1999 and the Pupil-teacher ratio(headcount basis) in Cyprus in 2000?
Your answer should be compact. 10.66. What is the difference between the Pupil-teacher ratio(headcount basis) in Cayman Islands in 1999 and the Pupil-teacher ratio(headcount basis) in Cyprus in 2000?
Give a very brief answer. -4.53. What is the average Pupil-teacher ratio(headcount basis) in Euro area per year?
Provide a short and direct response. 13.88. What is the average Pupil-teacher ratio(headcount basis) in Heavily indebted poor countries per year?
Make the answer very short. 25.23. What is the average Pupil-teacher ratio(headcount basis) in Cayman Islands per year?
Your answer should be very brief. 13.23. What is the average Pupil-teacher ratio(headcount basis) of Cyprus per year?
Keep it short and to the point. 17.33. In the year 1974, what is the difference between the Pupil-teacher ratio(headcount basis) in Euro area and Pupil-teacher ratio(headcount basis) in Heavily indebted poor countries?
Keep it short and to the point. -10.22. In the year 1974, what is the difference between the Pupil-teacher ratio(headcount basis) of Euro area and Pupil-teacher ratio(headcount basis) of Cayman Islands?
Your response must be concise. -3.56. In the year 1974, what is the difference between the Pupil-teacher ratio(headcount basis) of Euro area and Pupil-teacher ratio(headcount basis) of Cyprus?
Offer a very short reply. -4.12. In the year 1974, what is the difference between the Pupil-teacher ratio(headcount basis) in Heavily indebted poor countries and Pupil-teacher ratio(headcount basis) in Cayman Islands?
Your answer should be compact. 6.67. In the year 1974, what is the difference between the Pupil-teacher ratio(headcount basis) of Heavily indebted poor countries and Pupil-teacher ratio(headcount basis) of Cyprus?
Provide a succinct answer. 6.1. In the year 1974, what is the difference between the Pupil-teacher ratio(headcount basis) in Cayman Islands and Pupil-teacher ratio(headcount basis) in Cyprus?
Offer a terse response. -0.57. In the year 1975, what is the difference between the Pupil-teacher ratio(headcount basis) of Euro area and Pupil-teacher ratio(headcount basis) of Heavily indebted poor countries?
Make the answer very short. -10.75. In the year 1975, what is the difference between the Pupil-teacher ratio(headcount basis) of Euro area and Pupil-teacher ratio(headcount basis) of Cayman Islands?
Give a very brief answer. -4.17. In the year 1975, what is the difference between the Pupil-teacher ratio(headcount basis) in Euro area and Pupil-teacher ratio(headcount basis) in Cyprus?
Make the answer very short. -6.06. In the year 1975, what is the difference between the Pupil-teacher ratio(headcount basis) in Heavily indebted poor countries and Pupil-teacher ratio(headcount basis) in Cayman Islands?
Your answer should be compact. 6.59. In the year 1975, what is the difference between the Pupil-teacher ratio(headcount basis) in Heavily indebted poor countries and Pupil-teacher ratio(headcount basis) in Cyprus?
Keep it short and to the point. 4.69. In the year 1975, what is the difference between the Pupil-teacher ratio(headcount basis) of Cayman Islands and Pupil-teacher ratio(headcount basis) of Cyprus?
Provide a short and direct response. -1.9. In the year 1976, what is the difference between the Pupil-teacher ratio(headcount basis) of Euro area and Pupil-teacher ratio(headcount basis) of Heavily indebted poor countries?
Make the answer very short. -11.15. In the year 1976, what is the difference between the Pupil-teacher ratio(headcount basis) of Euro area and Pupil-teacher ratio(headcount basis) of Cayman Islands?
Provide a succinct answer. 0.46. In the year 1976, what is the difference between the Pupil-teacher ratio(headcount basis) of Euro area and Pupil-teacher ratio(headcount basis) of Cyprus?
Ensure brevity in your answer.  -5.58. In the year 1976, what is the difference between the Pupil-teacher ratio(headcount basis) in Heavily indebted poor countries and Pupil-teacher ratio(headcount basis) in Cayman Islands?
Your answer should be compact. 11.61. In the year 1976, what is the difference between the Pupil-teacher ratio(headcount basis) in Heavily indebted poor countries and Pupil-teacher ratio(headcount basis) in Cyprus?
Provide a short and direct response. 5.57. In the year 1976, what is the difference between the Pupil-teacher ratio(headcount basis) in Cayman Islands and Pupil-teacher ratio(headcount basis) in Cyprus?
Offer a very short reply. -6.04. In the year 1977, what is the difference between the Pupil-teacher ratio(headcount basis) in Euro area and Pupil-teacher ratio(headcount basis) in Heavily indebted poor countries?
Provide a short and direct response. -11.19. In the year 1977, what is the difference between the Pupil-teacher ratio(headcount basis) in Euro area and Pupil-teacher ratio(headcount basis) in Cayman Islands?
Keep it short and to the point. 0.71. In the year 1977, what is the difference between the Pupil-teacher ratio(headcount basis) in Euro area and Pupil-teacher ratio(headcount basis) in Cyprus?
Your answer should be compact. -4.94. In the year 1977, what is the difference between the Pupil-teacher ratio(headcount basis) of Heavily indebted poor countries and Pupil-teacher ratio(headcount basis) of Cayman Islands?
Keep it short and to the point. 11.9. In the year 1977, what is the difference between the Pupil-teacher ratio(headcount basis) in Heavily indebted poor countries and Pupil-teacher ratio(headcount basis) in Cyprus?
Keep it short and to the point. 6.25. In the year 1977, what is the difference between the Pupil-teacher ratio(headcount basis) in Cayman Islands and Pupil-teacher ratio(headcount basis) in Cyprus?
Your answer should be very brief. -5.65. In the year 1980, what is the difference between the Pupil-teacher ratio(headcount basis) of Euro area and Pupil-teacher ratio(headcount basis) of Heavily indebted poor countries?
Make the answer very short. -11.75. In the year 1980, what is the difference between the Pupil-teacher ratio(headcount basis) in Euro area and Pupil-teacher ratio(headcount basis) in Cayman Islands?
Offer a terse response. 1.97. In the year 1980, what is the difference between the Pupil-teacher ratio(headcount basis) in Euro area and Pupil-teacher ratio(headcount basis) in Cyprus?
Make the answer very short. -2.48. In the year 1980, what is the difference between the Pupil-teacher ratio(headcount basis) in Heavily indebted poor countries and Pupil-teacher ratio(headcount basis) in Cayman Islands?
Provide a succinct answer. 13.72. In the year 1980, what is the difference between the Pupil-teacher ratio(headcount basis) in Heavily indebted poor countries and Pupil-teacher ratio(headcount basis) in Cyprus?
Your answer should be very brief. 9.27. In the year 1980, what is the difference between the Pupil-teacher ratio(headcount basis) of Cayman Islands and Pupil-teacher ratio(headcount basis) of Cyprus?
Ensure brevity in your answer.  -4.45. In the year 1981, what is the difference between the Pupil-teacher ratio(headcount basis) of Euro area and Pupil-teacher ratio(headcount basis) of Heavily indebted poor countries?
Your response must be concise. -11.7. In the year 1981, what is the difference between the Pupil-teacher ratio(headcount basis) of Euro area and Pupil-teacher ratio(headcount basis) of Cayman Islands?
Ensure brevity in your answer.  3.86. In the year 1981, what is the difference between the Pupil-teacher ratio(headcount basis) in Euro area and Pupil-teacher ratio(headcount basis) in Cyprus?
Keep it short and to the point. -2.24. In the year 1981, what is the difference between the Pupil-teacher ratio(headcount basis) in Heavily indebted poor countries and Pupil-teacher ratio(headcount basis) in Cayman Islands?
Your answer should be very brief. 15.56. In the year 1981, what is the difference between the Pupil-teacher ratio(headcount basis) of Heavily indebted poor countries and Pupil-teacher ratio(headcount basis) of Cyprus?
Your response must be concise. 9.47. In the year 1981, what is the difference between the Pupil-teacher ratio(headcount basis) of Cayman Islands and Pupil-teacher ratio(headcount basis) of Cyprus?
Your answer should be very brief. -6.09. In the year 1999, what is the difference between the Pupil-teacher ratio(headcount basis) in Euro area and Pupil-teacher ratio(headcount basis) in Heavily indebted poor countries?
Your response must be concise. -11.9. In the year 1999, what is the difference between the Pupil-teacher ratio(headcount basis) of Euro area and Pupil-teacher ratio(headcount basis) of Cayman Islands?
Your answer should be very brief. 3.28. In the year 1999, what is the difference between the Pupil-teacher ratio(headcount basis) in Euro area and Pupil-teacher ratio(headcount basis) in Cyprus?
Your answer should be compact. -0.51. In the year 1999, what is the difference between the Pupil-teacher ratio(headcount basis) of Heavily indebted poor countries and Pupil-teacher ratio(headcount basis) of Cayman Islands?
Your response must be concise. 15.19. In the year 1999, what is the difference between the Pupil-teacher ratio(headcount basis) in Heavily indebted poor countries and Pupil-teacher ratio(headcount basis) in Cyprus?
Offer a terse response. 11.39. In the year 1999, what is the difference between the Pupil-teacher ratio(headcount basis) of Cayman Islands and Pupil-teacher ratio(headcount basis) of Cyprus?
Keep it short and to the point. -3.79. In the year 2000, what is the difference between the Pupil-teacher ratio(headcount basis) in Euro area and Pupil-teacher ratio(headcount basis) in Heavily indebted poor countries?
Offer a very short reply. -12.09. In the year 2000, what is the difference between the Pupil-teacher ratio(headcount basis) in Euro area and Pupil-teacher ratio(headcount basis) in Cayman Islands?
Your response must be concise. 2.71. In the year 2000, what is the difference between the Pupil-teacher ratio(headcount basis) of Euro area and Pupil-teacher ratio(headcount basis) of Cyprus?
Offer a very short reply. -1.6. In the year 2000, what is the difference between the Pupil-teacher ratio(headcount basis) in Heavily indebted poor countries and Pupil-teacher ratio(headcount basis) in Cayman Islands?
Keep it short and to the point. 14.8. In the year 2000, what is the difference between the Pupil-teacher ratio(headcount basis) in Heavily indebted poor countries and Pupil-teacher ratio(headcount basis) in Cyprus?
Provide a succinct answer. 10.49. In the year 2000, what is the difference between the Pupil-teacher ratio(headcount basis) in Cayman Islands and Pupil-teacher ratio(headcount basis) in Cyprus?
Offer a very short reply. -4.31. What is the ratio of the Pupil-teacher ratio(headcount basis) of Euro area in 1974 to that in 1975?
Your response must be concise. 1.02. What is the ratio of the Pupil-teacher ratio(headcount basis) in Heavily indebted poor countries in 1974 to that in 1975?
Offer a terse response. 0.99. What is the ratio of the Pupil-teacher ratio(headcount basis) in Cayman Islands in 1974 to that in 1975?
Make the answer very short. 0.98. What is the ratio of the Pupil-teacher ratio(headcount basis) of Cyprus in 1974 to that in 1975?
Provide a succinct answer. 0.92. What is the ratio of the Pupil-teacher ratio(headcount basis) in Euro area in 1974 to that in 1976?
Offer a very short reply. 1.03. What is the ratio of the Pupil-teacher ratio(headcount basis) in Heavily indebted poor countries in 1974 to that in 1976?
Your answer should be compact. 0.98. What is the ratio of the Pupil-teacher ratio(headcount basis) of Cayman Islands in 1974 to that in 1976?
Offer a very short reply. 1.32. What is the ratio of the Pupil-teacher ratio(headcount basis) of Cyprus in 1974 to that in 1976?
Give a very brief answer. 0.95. What is the ratio of the Pupil-teacher ratio(headcount basis) in Euro area in 1974 to that in 1977?
Your response must be concise. 1.05. What is the ratio of the Pupil-teacher ratio(headcount basis) of Cayman Islands in 1974 to that in 1977?
Provide a short and direct response. 1.36. What is the ratio of the Pupil-teacher ratio(headcount basis) of Cyprus in 1974 to that in 1977?
Your answer should be compact. 0.99. What is the ratio of the Pupil-teacher ratio(headcount basis) in Euro area in 1974 to that in 1980?
Provide a short and direct response. 1.07. What is the ratio of the Pupil-teacher ratio(headcount basis) in Heavily indebted poor countries in 1974 to that in 1980?
Your answer should be compact. 0.98. What is the ratio of the Pupil-teacher ratio(headcount basis) of Cayman Islands in 1974 to that in 1980?
Keep it short and to the point. 1.54. What is the ratio of the Pupil-teacher ratio(headcount basis) of Cyprus in 1974 to that in 1980?
Offer a terse response. 1.16. What is the ratio of the Pupil-teacher ratio(headcount basis) in Euro area in 1974 to that in 1981?
Your answer should be compact. 1.08. What is the ratio of the Pupil-teacher ratio(headcount basis) in Heavily indebted poor countries in 1974 to that in 1981?
Offer a terse response. 0.99. What is the ratio of the Pupil-teacher ratio(headcount basis) of Cayman Islands in 1974 to that in 1981?
Offer a terse response. 1.86. What is the ratio of the Pupil-teacher ratio(headcount basis) of Cyprus in 1974 to that in 1981?
Give a very brief answer. 1.19. What is the ratio of the Pupil-teacher ratio(headcount basis) in Euro area in 1974 to that in 1999?
Make the answer very short. 1.22. What is the ratio of the Pupil-teacher ratio(headcount basis) in Heavily indebted poor countries in 1974 to that in 1999?
Offer a terse response. 1.04. What is the ratio of the Pupil-teacher ratio(headcount basis) in Cayman Islands in 1974 to that in 1999?
Your answer should be compact. 2.05. What is the ratio of the Pupil-teacher ratio(headcount basis) in Cyprus in 1974 to that in 1999?
Provide a succinct answer. 1.49. What is the ratio of the Pupil-teacher ratio(headcount basis) of Euro area in 1974 to that in 2000?
Keep it short and to the point. 1.25. What is the ratio of the Pupil-teacher ratio(headcount basis) in Heavily indebted poor countries in 1974 to that in 2000?
Your answer should be very brief. 1.05. What is the ratio of the Pupil-teacher ratio(headcount basis) in Cayman Islands in 1974 to that in 2000?
Your answer should be compact. 2. What is the ratio of the Pupil-teacher ratio(headcount basis) of Cyprus in 1974 to that in 2000?
Ensure brevity in your answer.  1.41. What is the ratio of the Pupil-teacher ratio(headcount basis) of Euro area in 1975 to that in 1976?
Your response must be concise. 1.02. What is the ratio of the Pupil-teacher ratio(headcount basis) in Heavily indebted poor countries in 1975 to that in 1976?
Ensure brevity in your answer.  0.99. What is the ratio of the Pupil-teacher ratio(headcount basis) in Cayman Islands in 1975 to that in 1976?
Your response must be concise. 1.35. What is the ratio of the Pupil-teacher ratio(headcount basis) in Cyprus in 1975 to that in 1976?
Your response must be concise. 1.04. What is the ratio of the Pupil-teacher ratio(headcount basis) of Euro area in 1975 to that in 1977?
Offer a very short reply. 1.03. What is the ratio of the Pupil-teacher ratio(headcount basis) in Heavily indebted poor countries in 1975 to that in 1977?
Your answer should be compact. 1. What is the ratio of the Pupil-teacher ratio(headcount basis) in Cayman Islands in 1975 to that in 1977?
Make the answer very short. 1.39. What is the ratio of the Pupil-teacher ratio(headcount basis) of Cyprus in 1975 to that in 1977?
Offer a terse response. 1.08. What is the ratio of the Pupil-teacher ratio(headcount basis) in Euro area in 1975 to that in 1980?
Make the answer very short. 1.06. What is the ratio of the Pupil-teacher ratio(headcount basis) in Cayman Islands in 1975 to that in 1980?
Make the answer very short. 1.57. What is the ratio of the Pupil-teacher ratio(headcount basis) of Cyprus in 1975 to that in 1980?
Your response must be concise. 1.26. What is the ratio of the Pupil-teacher ratio(headcount basis) in Euro area in 1975 to that in 1981?
Provide a succinct answer. 1.07. What is the ratio of the Pupil-teacher ratio(headcount basis) in Heavily indebted poor countries in 1975 to that in 1981?
Offer a terse response. 1. What is the ratio of the Pupil-teacher ratio(headcount basis) of Cayman Islands in 1975 to that in 1981?
Offer a very short reply. 1.89. What is the ratio of the Pupil-teacher ratio(headcount basis) of Cyprus in 1975 to that in 1981?
Keep it short and to the point. 1.29. What is the ratio of the Pupil-teacher ratio(headcount basis) of Euro area in 1975 to that in 1999?
Give a very brief answer. 1.2. What is the ratio of the Pupil-teacher ratio(headcount basis) of Heavily indebted poor countries in 1975 to that in 1999?
Make the answer very short. 1.05. What is the ratio of the Pupil-teacher ratio(headcount basis) of Cayman Islands in 1975 to that in 1999?
Provide a succinct answer. 2.09. What is the ratio of the Pupil-teacher ratio(headcount basis) in Cyprus in 1975 to that in 1999?
Your response must be concise. 1.62. What is the ratio of the Pupil-teacher ratio(headcount basis) of Euro area in 1975 to that in 2000?
Your answer should be very brief. 1.23. What is the ratio of the Pupil-teacher ratio(headcount basis) of Heavily indebted poor countries in 1975 to that in 2000?
Make the answer very short. 1.06. What is the ratio of the Pupil-teacher ratio(headcount basis) in Cayman Islands in 1975 to that in 2000?
Provide a short and direct response. 2.04. What is the ratio of the Pupil-teacher ratio(headcount basis) of Cyprus in 1975 to that in 2000?
Your answer should be very brief. 1.53. What is the ratio of the Pupil-teacher ratio(headcount basis) in Euro area in 1976 to that in 1977?
Make the answer very short. 1.01. What is the ratio of the Pupil-teacher ratio(headcount basis) of Heavily indebted poor countries in 1976 to that in 1977?
Your response must be concise. 1.01. What is the ratio of the Pupil-teacher ratio(headcount basis) of Cayman Islands in 1976 to that in 1977?
Give a very brief answer. 1.03. What is the ratio of the Pupil-teacher ratio(headcount basis) in Cyprus in 1976 to that in 1977?
Offer a terse response. 1.04. What is the ratio of the Pupil-teacher ratio(headcount basis) of Euro area in 1976 to that in 1980?
Ensure brevity in your answer.  1.04. What is the ratio of the Pupil-teacher ratio(headcount basis) of Cayman Islands in 1976 to that in 1980?
Your answer should be compact. 1.17. What is the ratio of the Pupil-teacher ratio(headcount basis) in Cyprus in 1976 to that in 1980?
Your answer should be compact. 1.22. What is the ratio of the Pupil-teacher ratio(headcount basis) in Euro area in 1976 to that in 1981?
Offer a terse response. 1.05. What is the ratio of the Pupil-teacher ratio(headcount basis) in Cayman Islands in 1976 to that in 1981?
Offer a terse response. 1.41. What is the ratio of the Pupil-teacher ratio(headcount basis) of Cyprus in 1976 to that in 1981?
Make the answer very short. 1.25. What is the ratio of the Pupil-teacher ratio(headcount basis) of Euro area in 1976 to that in 1999?
Give a very brief answer. 1.18. What is the ratio of the Pupil-teacher ratio(headcount basis) of Heavily indebted poor countries in 1976 to that in 1999?
Keep it short and to the point. 1.06. What is the ratio of the Pupil-teacher ratio(headcount basis) in Cayman Islands in 1976 to that in 1999?
Your response must be concise. 1.55. What is the ratio of the Pupil-teacher ratio(headcount basis) of Cyprus in 1976 to that in 1999?
Give a very brief answer. 1.57. What is the ratio of the Pupil-teacher ratio(headcount basis) of Euro area in 1976 to that in 2000?
Give a very brief answer. 1.21. What is the ratio of the Pupil-teacher ratio(headcount basis) in Heavily indebted poor countries in 1976 to that in 2000?
Your answer should be very brief. 1.07. What is the ratio of the Pupil-teacher ratio(headcount basis) in Cayman Islands in 1976 to that in 2000?
Your answer should be compact. 1.52. What is the ratio of the Pupil-teacher ratio(headcount basis) in Cyprus in 1976 to that in 2000?
Your answer should be compact. 1.48. What is the ratio of the Pupil-teacher ratio(headcount basis) in Euro area in 1977 to that in 1980?
Keep it short and to the point. 1.03. What is the ratio of the Pupil-teacher ratio(headcount basis) of Cayman Islands in 1977 to that in 1980?
Offer a very short reply. 1.13. What is the ratio of the Pupil-teacher ratio(headcount basis) in Cyprus in 1977 to that in 1980?
Ensure brevity in your answer.  1.17. What is the ratio of the Pupil-teacher ratio(headcount basis) of Euro area in 1977 to that in 1981?
Ensure brevity in your answer.  1.04. What is the ratio of the Pupil-teacher ratio(headcount basis) of Cayman Islands in 1977 to that in 1981?
Your answer should be very brief. 1.36. What is the ratio of the Pupil-teacher ratio(headcount basis) in Cyprus in 1977 to that in 1981?
Provide a succinct answer. 1.2. What is the ratio of the Pupil-teacher ratio(headcount basis) of Euro area in 1977 to that in 1999?
Offer a very short reply. 1.16. What is the ratio of the Pupil-teacher ratio(headcount basis) in Heavily indebted poor countries in 1977 to that in 1999?
Ensure brevity in your answer.  1.05. What is the ratio of the Pupil-teacher ratio(headcount basis) in Cayman Islands in 1977 to that in 1999?
Offer a very short reply. 1.51. What is the ratio of the Pupil-teacher ratio(headcount basis) of Cyprus in 1977 to that in 1999?
Make the answer very short. 1.5. What is the ratio of the Pupil-teacher ratio(headcount basis) in Euro area in 1977 to that in 2000?
Your response must be concise. 1.2. What is the ratio of the Pupil-teacher ratio(headcount basis) of Heavily indebted poor countries in 1977 to that in 2000?
Ensure brevity in your answer.  1.06. What is the ratio of the Pupil-teacher ratio(headcount basis) of Cayman Islands in 1977 to that in 2000?
Give a very brief answer. 1.47. What is the ratio of the Pupil-teacher ratio(headcount basis) in Cyprus in 1977 to that in 2000?
Keep it short and to the point. 1.42. What is the ratio of the Pupil-teacher ratio(headcount basis) in Euro area in 1980 to that in 1981?
Keep it short and to the point. 1.01. What is the ratio of the Pupil-teacher ratio(headcount basis) of Heavily indebted poor countries in 1980 to that in 1981?
Make the answer very short. 1.01. What is the ratio of the Pupil-teacher ratio(headcount basis) of Cayman Islands in 1980 to that in 1981?
Ensure brevity in your answer.  1.2. What is the ratio of the Pupil-teacher ratio(headcount basis) in Cyprus in 1980 to that in 1981?
Provide a short and direct response. 1.02. What is the ratio of the Pupil-teacher ratio(headcount basis) of Euro area in 1980 to that in 1999?
Keep it short and to the point. 1.13. What is the ratio of the Pupil-teacher ratio(headcount basis) in Heavily indebted poor countries in 1980 to that in 1999?
Provide a succinct answer. 1.06. What is the ratio of the Pupil-teacher ratio(headcount basis) in Cayman Islands in 1980 to that in 1999?
Keep it short and to the point. 1.33. What is the ratio of the Pupil-teacher ratio(headcount basis) of Cyprus in 1980 to that in 1999?
Provide a short and direct response. 1.28. What is the ratio of the Pupil-teacher ratio(headcount basis) in Euro area in 1980 to that in 2000?
Ensure brevity in your answer.  1.17. What is the ratio of the Pupil-teacher ratio(headcount basis) of Heavily indebted poor countries in 1980 to that in 2000?
Offer a very short reply. 1.07. What is the ratio of the Pupil-teacher ratio(headcount basis) of Cayman Islands in 1980 to that in 2000?
Offer a terse response. 1.3. What is the ratio of the Pupil-teacher ratio(headcount basis) of Cyprus in 1980 to that in 2000?
Offer a very short reply. 1.21. What is the ratio of the Pupil-teacher ratio(headcount basis) in Euro area in 1981 to that in 1999?
Keep it short and to the point. 1.12. What is the ratio of the Pupil-teacher ratio(headcount basis) of Heavily indebted poor countries in 1981 to that in 1999?
Your answer should be compact. 1.05. What is the ratio of the Pupil-teacher ratio(headcount basis) of Cayman Islands in 1981 to that in 1999?
Keep it short and to the point. 1.1. What is the ratio of the Pupil-teacher ratio(headcount basis) in Cyprus in 1981 to that in 1999?
Keep it short and to the point. 1.25. What is the ratio of the Pupil-teacher ratio(headcount basis) in Euro area in 1981 to that in 2000?
Give a very brief answer. 1.16. What is the ratio of the Pupil-teacher ratio(headcount basis) of Heavily indebted poor countries in 1981 to that in 2000?
Offer a terse response. 1.06. What is the ratio of the Pupil-teacher ratio(headcount basis) in Cayman Islands in 1981 to that in 2000?
Keep it short and to the point. 1.08. What is the ratio of the Pupil-teacher ratio(headcount basis) in Cyprus in 1981 to that in 2000?
Your response must be concise. 1.18. What is the ratio of the Pupil-teacher ratio(headcount basis) in Euro area in 1999 to that in 2000?
Your response must be concise. 1.03. What is the ratio of the Pupil-teacher ratio(headcount basis) of Heavily indebted poor countries in 1999 to that in 2000?
Make the answer very short. 1.01. What is the ratio of the Pupil-teacher ratio(headcount basis) in Cayman Islands in 1999 to that in 2000?
Offer a terse response. 0.98. What is the ratio of the Pupil-teacher ratio(headcount basis) of Cyprus in 1999 to that in 2000?
Keep it short and to the point. 0.95. What is the difference between the highest and the second highest Pupil-teacher ratio(headcount basis) in Euro area?
Provide a succinct answer. 0.24. What is the difference between the highest and the second highest Pupil-teacher ratio(headcount basis) in Heavily indebted poor countries?
Ensure brevity in your answer.  0.06. What is the difference between the highest and the second highest Pupil-teacher ratio(headcount basis) of Cayman Islands?
Offer a very short reply. 0.36. What is the difference between the highest and the second highest Pupil-teacher ratio(headcount basis) in Cyprus?
Your answer should be very brief. 0.73. What is the difference between the highest and the lowest Pupil-teacher ratio(headcount basis) of Euro area?
Offer a terse response. 3.05. What is the difference between the highest and the lowest Pupil-teacher ratio(headcount basis) in Heavily indebted poor countries?
Your answer should be compact. 1.67. What is the difference between the highest and the lowest Pupil-teacher ratio(headcount basis) in Cayman Islands?
Your response must be concise. 9.9. What is the difference between the highest and the lowest Pupil-teacher ratio(headcount basis) in Cyprus?
Ensure brevity in your answer.  8.01. 